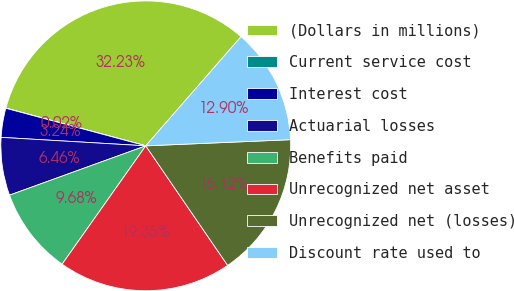Convert chart. <chart><loc_0><loc_0><loc_500><loc_500><pie_chart><fcel>(Dollars in millions)<fcel>Current service cost<fcel>Interest cost<fcel>Actuarial losses<fcel>Benefits paid<fcel>Unrecognized net asset<fcel>Unrecognized net (losses)<fcel>Discount rate used to<nl><fcel>32.23%<fcel>0.02%<fcel>3.24%<fcel>6.46%<fcel>9.68%<fcel>19.35%<fcel>16.12%<fcel>12.9%<nl></chart> 